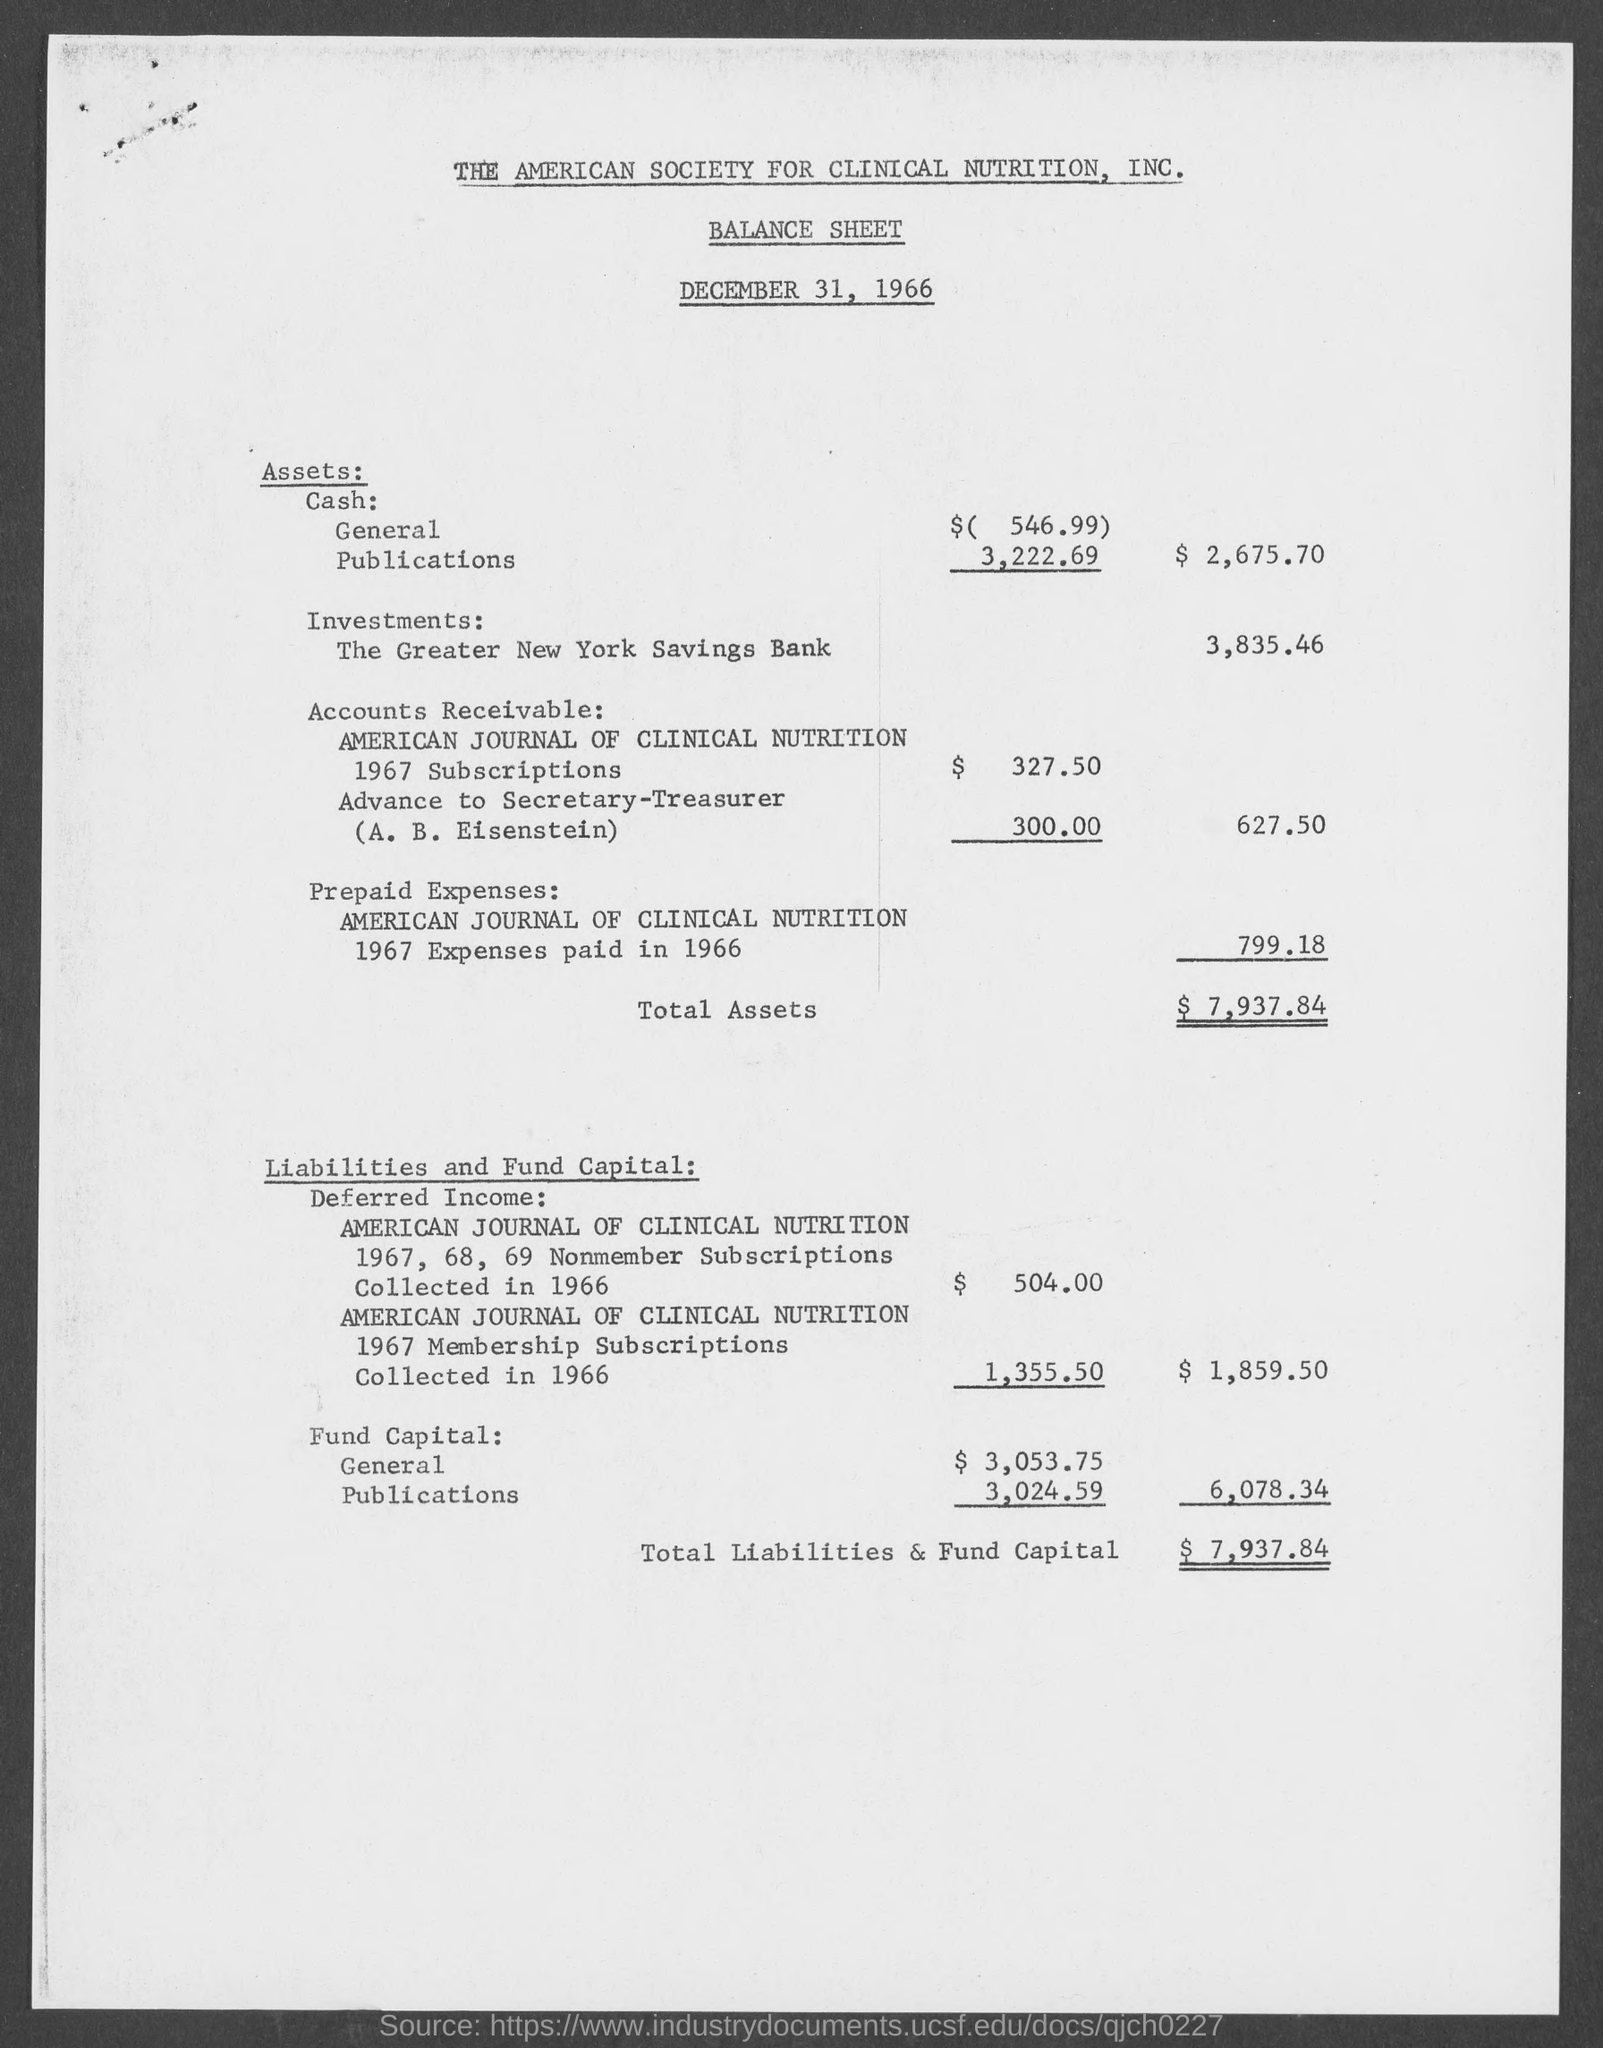What is the issued date of the Balance sheet?
Offer a terse response. DECEMBER 31, 1966. What is the amount of Total Assets given in the balance sheet?
Provide a short and direct response. $7,937.84. What is the amount of total Liabilities & Fund Capital given in the balance sheet?
Your answer should be very brief. $ 7,937.84. 